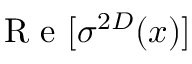<formula> <loc_0><loc_0><loc_500><loc_500>R e [ \sigma ^ { 2 D } ( x ) ]</formula> 